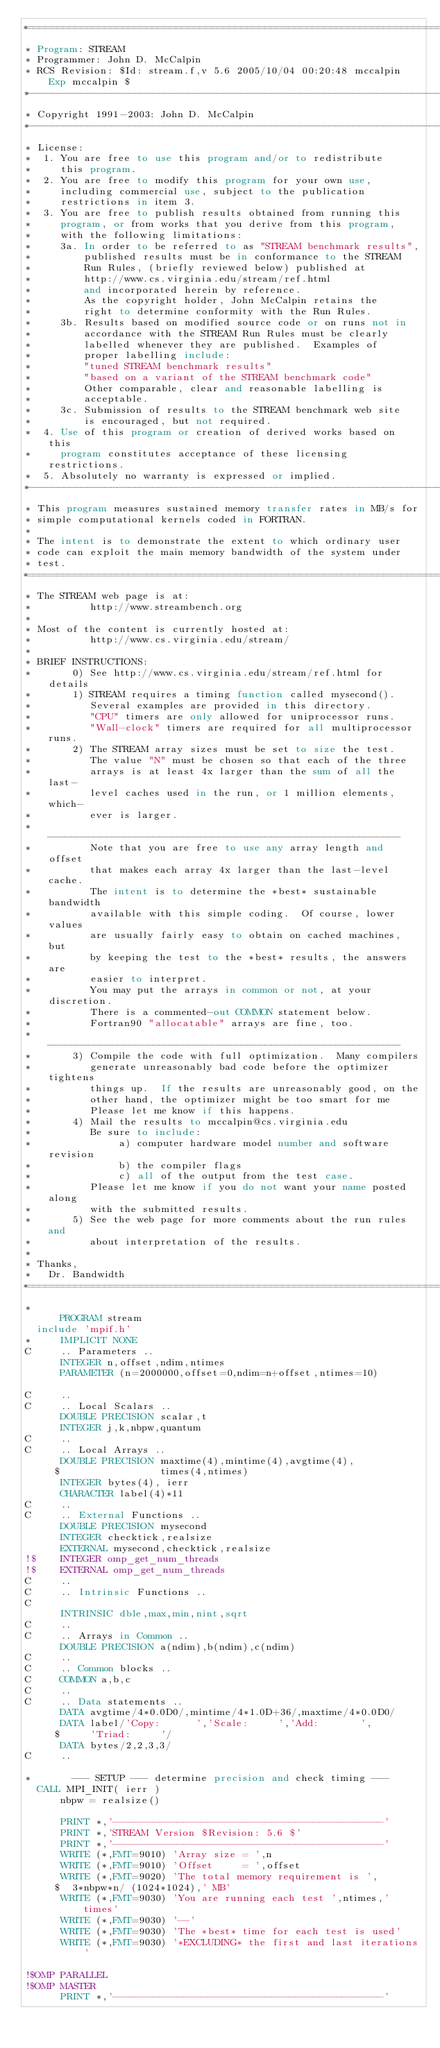<code> <loc_0><loc_0><loc_500><loc_500><_FORTRAN_>*=======================================================================
* Program: STREAM
* Programmer: John D. McCalpin
* RCS Revision: $Id: stream.f,v 5.6 2005/10/04 00:20:48 mccalpin Exp mccalpin $
*-----------------------------------------------------------------------
* Copyright 1991-2003: John D. McCalpin
*-----------------------------------------------------------------------
* License:
*  1. You are free to use this program and/or to redistribute
*     this program.
*  2. You are free to modify this program for your own use,
*     including commercial use, subject to the publication
*     restrictions in item 3.
*  3. You are free to publish results obtained from running this
*     program, or from works that you derive from this program,
*     with the following limitations:
*     3a. In order to be referred to as "STREAM benchmark results",
*         published results must be in conformance to the STREAM
*         Run Rules, (briefly reviewed below) published at
*         http://www.cs.virginia.edu/stream/ref.html
*         and incorporated herein by reference.
*         As the copyright holder, John McCalpin retains the
*         right to determine conformity with the Run Rules.
*     3b. Results based on modified source code or on runs not in
*         accordance with the STREAM Run Rules must be clearly
*         labelled whenever they are published.  Examples of
*         proper labelling include:
*         "tuned STREAM benchmark results" 
*         "based on a variant of the STREAM benchmark code"
*         Other comparable, clear and reasonable labelling is
*         acceptable.
*     3c. Submission of results to the STREAM benchmark web site
*         is encouraged, but not required.
*  4. Use of this program or creation of derived works based on this
*     program constitutes acceptance of these licensing restrictions.
*  5. Absolutely no warranty is expressed or implied.
*-----------------------------------------------------------------------
* This program measures sustained memory transfer rates in MB/s for
* simple computational kernels coded in FORTRAN.
*
* The intent is to demonstrate the extent to which ordinary user
* code can exploit the main memory bandwidth of the system under
* test.
*=======================================================================
* The STREAM web page is at:
*          http://www.streambench.org
*
* Most of the content is currently hosted at:
*          http://www.cs.virginia.edu/stream/
*
* BRIEF INSTRUCTIONS: 
*       0) See http://www.cs.virginia.edu/stream/ref.html for details
*       1) STREAM requires a timing function called mysecond().
*          Several examples are provided in this directory.
*          "CPU" timers are only allowed for uniprocessor runs.
*          "Wall-clock" timers are required for all multiprocessor runs.
*       2) The STREAM array sizes must be set to size the test.
*          The value "N" must be chosen so that each of the three
*          arrays is at least 4x larger than the sum of all the last-
*          level caches used in the run, or 1 million elements, which-
*          ever is larger.
*          ------------------------------------------------------------
*          Note that you are free to use any array length and offset
*          that makes each array 4x larger than the last-level cache.
*          The intent is to determine the *best* sustainable bandwidth
*          available with this simple coding.  Of course, lower values
*          are usually fairly easy to obtain on cached machines, but 
*          by keeping the test to the *best* results, the answers are
*          easier to interpret.
*          You may put the arrays in common or not, at your discretion.
*          There is a commented-out COMMON statement below.
*          Fortran90 "allocatable" arrays are fine, too.
*          ------------------------------------------------------------
*       3) Compile the code with full optimization.  Many compilers
*          generate unreasonably bad code before the optimizer tightens
*          things up.  If the results are unreasonably good, on the
*          other hand, the optimizer might be too smart for me
*          Please let me know if this happens.
*       4) Mail the results to mccalpin@cs.virginia.edu
*          Be sure to include:
*               a) computer hardware model number and software revision
*               b) the compiler flags
*               c) all of the output from the test case.
*          Please let me know if you do not want your name posted along
*          with the submitted results.
*       5) See the web page for more comments about the run rules and
*          about interpretation of the results.
*
* Thanks,
*   Dr. Bandwidth
*=========================================================================
*
      PROGRAM stream
	include 'mpif.h'
*     IMPLICIT NONE
C     .. Parameters ..
      INTEGER n,offset,ndim,ntimes
      PARAMETER (n=2000000,offset=0,ndim=n+offset,ntimes=10)

C     ..
C     .. Local Scalars ..
      DOUBLE PRECISION scalar,t
      INTEGER j,k,nbpw,quantum
C     ..
C     .. Local Arrays ..
      DOUBLE PRECISION maxtime(4),mintime(4),avgtime(4),
     $                 times(4,ntimes)
      INTEGER bytes(4), ierr
      CHARACTER label(4)*11
C     ..
C     .. External Functions ..
      DOUBLE PRECISION mysecond
      INTEGER checktick,realsize
      EXTERNAL mysecond,checktick,realsize
!$    INTEGER omp_get_num_threads
!$    EXTERNAL omp_get_num_threads
C     ..
C     .. Intrinsic Functions ..
C
      INTRINSIC dble,max,min,nint,sqrt
C     ..
C     .. Arrays in Common ..
      DOUBLE PRECISION a(ndim),b(ndim),c(ndim)
C     ..
C     .. Common blocks ..
C     COMMON a,b,c
C     ..
C     .. Data statements ..
      DATA avgtime/4*0.0D0/,mintime/4*1.0D+36/,maxtime/4*0.0D0/
      DATA label/'Copy:      ','Scale:     ','Add:       ',
     $     'Triad:     '/
      DATA bytes/2,2,3,3/
C     ..

*       --- SETUP --- determine precision and check timing ---
	CALL MPI_INIT( ierr )
      nbpw = realsize()

      PRINT *,'----------------------------------------------'
      PRINT *,'STREAM Version $Revision: 5.6 $'
      PRINT *,'----------------------------------------------'
      WRITE (*,FMT=9010) 'Array size = ',n
      WRITE (*,FMT=9010) 'Offset     = ',offset
      WRITE (*,FMT=9020) 'The total memory requirement is ',
     $  3*nbpw*n/ (1024*1024),' MB'
      WRITE (*,FMT=9030) 'You are running each test ',ntimes,' times'
      WRITE (*,FMT=9030) '--'
      WRITE (*,FMT=9030) 'The *best* time for each test is used'
      WRITE (*,FMT=9030) '*EXCLUDING* the first and last iterations'

!$OMP PARALLEL
!$OMP MASTER
      PRINT *,'----------------------------------------------'</code> 